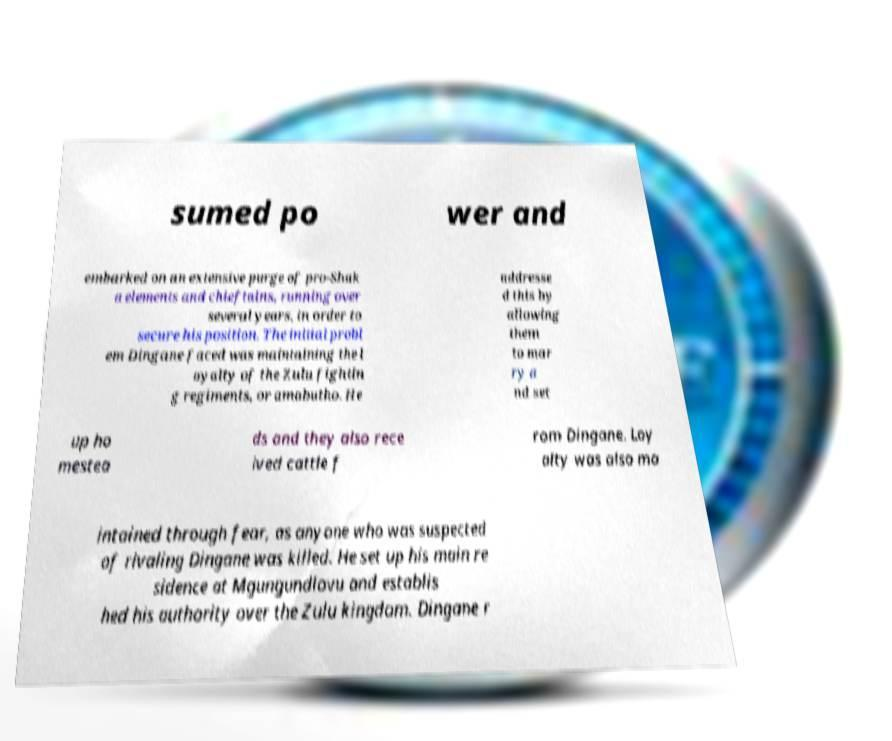What messages or text are displayed in this image? I need them in a readable, typed format. sumed po wer and embarked on an extensive purge of pro-Shak a elements and chieftains, running over several years, in order to secure his position. The initial probl em Dingane faced was maintaining the l oyalty of the Zulu fightin g regiments, or amabutho. He addresse d this by allowing them to mar ry a nd set up ho mestea ds and they also rece ived cattle f rom Dingane. Loy alty was also ma intained through fear, as anyone who was suspected of rivaling Dingane was killed. He set up his main re sidence at Mgungundlovu and establis hed his authority over the Zulu kingdom. Dingane r 